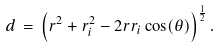Convert formula to latex. <formula><loc_0><loc_0><loc_500><loc_500>d \, = \, \left ( r ^ { 2 } + r _ { i } ^ { 2 } - 2 r r _ { i } \cos ( \theta ) \right ) ^ { \frac { 1 } { 2 } } .</formula> 